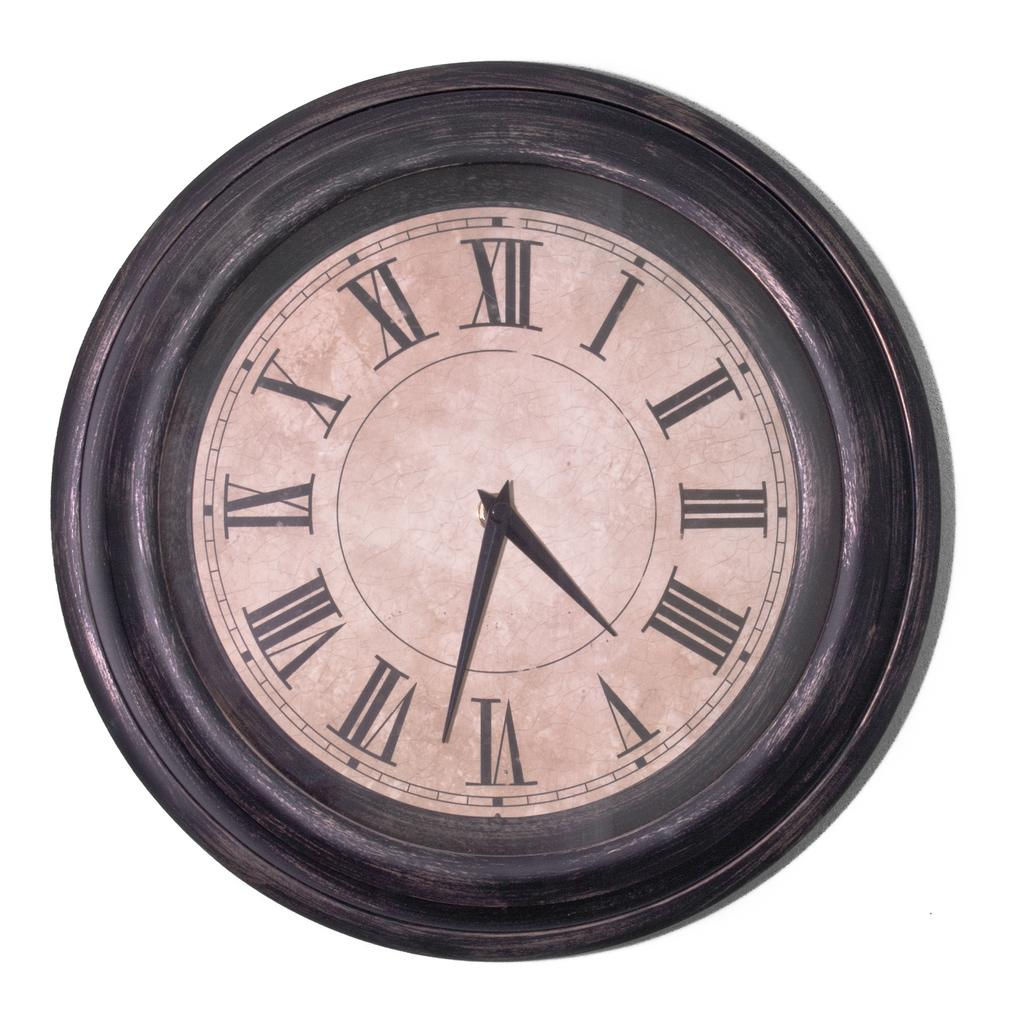<image>
Describe the image concisely. A worn-looking clock has the numeral III on the right side and IX on the left side. 